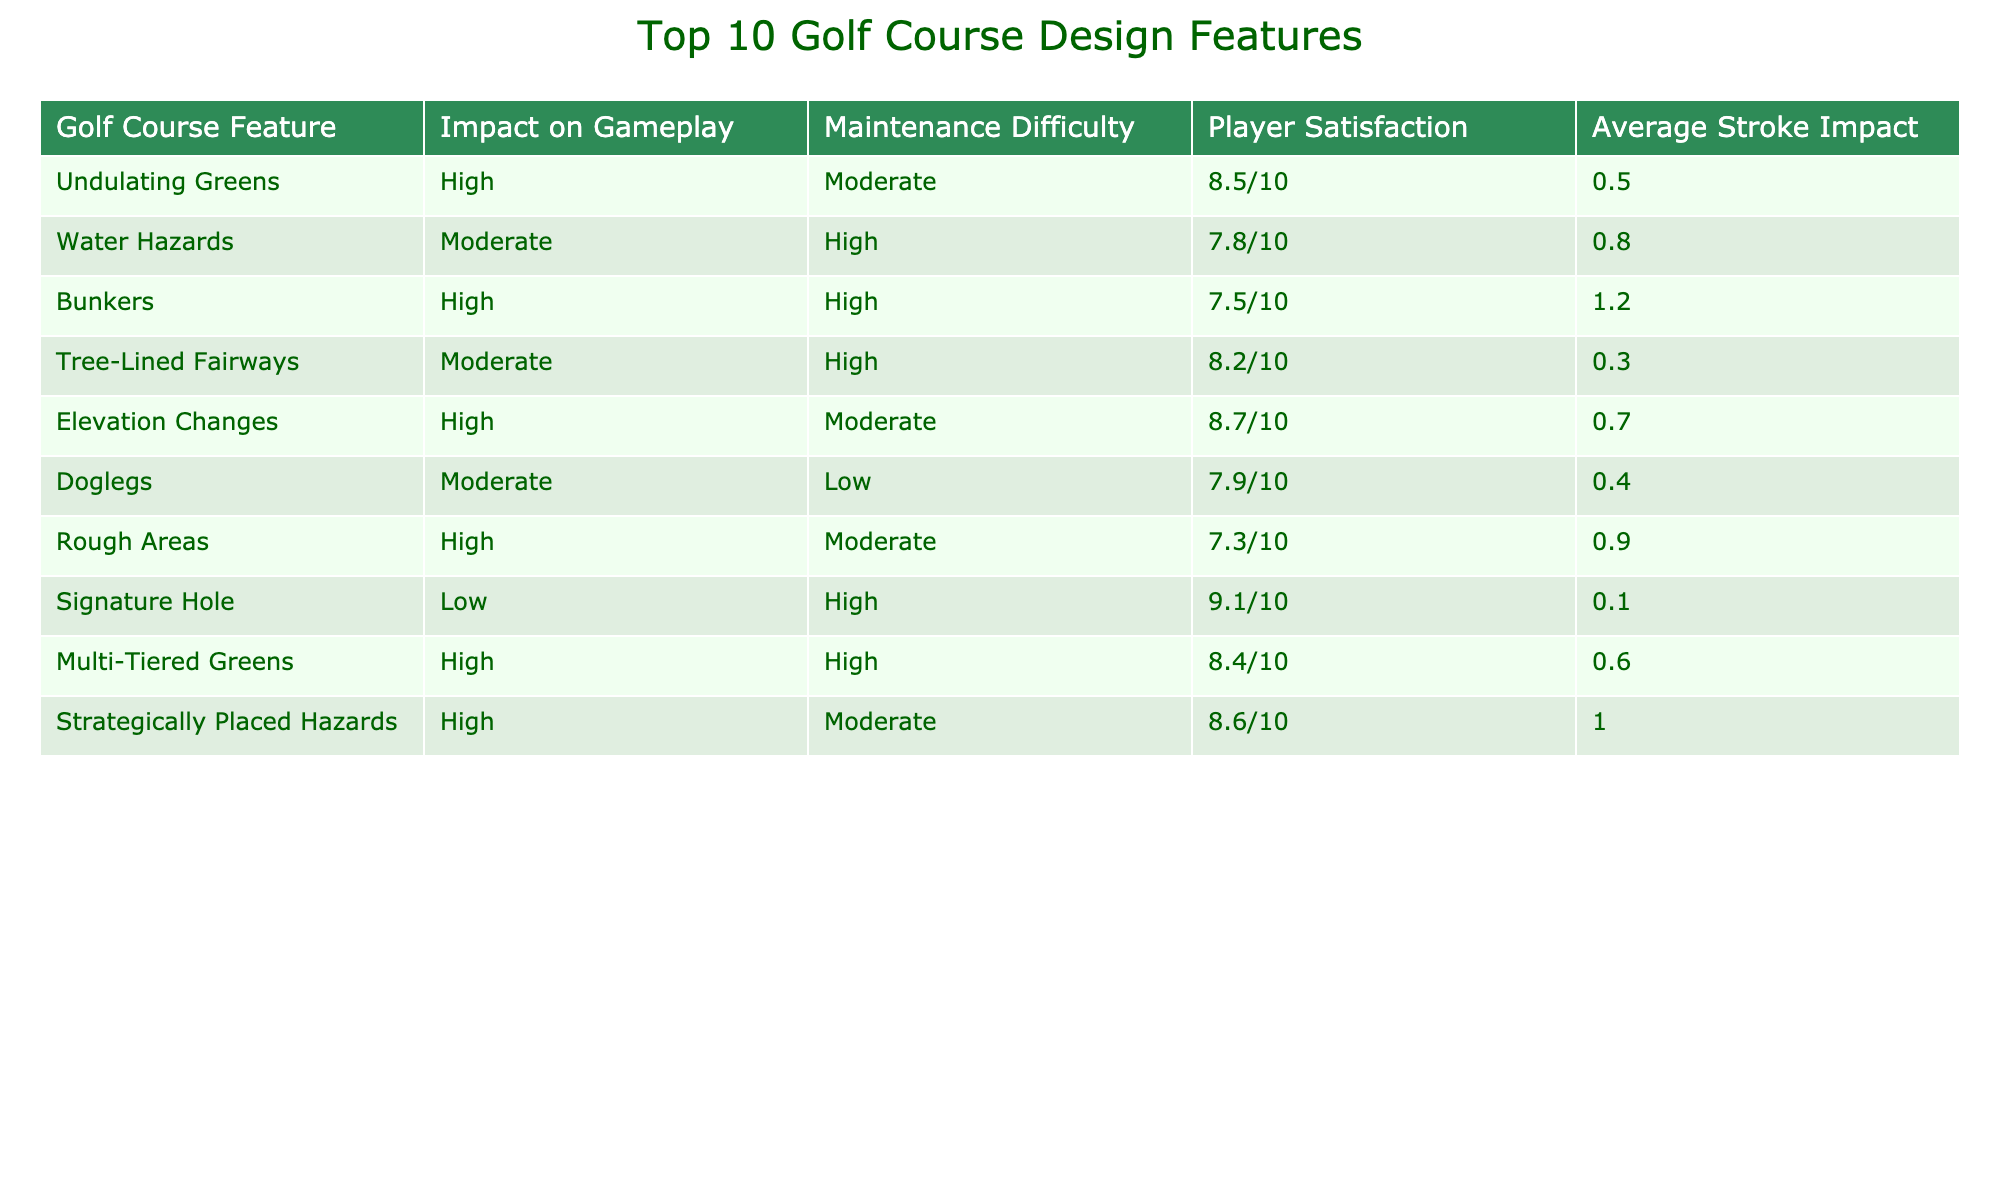What is the average player satisfaction rating for the golf course features? To find the average player satisfaction rating, we take the sum of all satisfaction ratings (8.5 + 7.8 + 7.5 + 8.2 + 8.7 + 7.9 + 7.3 + 9.1 + 8.4 + 8.6) which equals 86.6, and then divide by the number of features (10). Thus, 86.6 / 10 = 8.66.
Answer: 8.66 Which feature has the highest average stroke impact? By reviewing the "Average Stroke Impact" column, we find that Bunkers have the highest value at +1.2.
Answer: Bunkers Is "Elevation Changes" considered to have a high impact on gameplay? The table indicates that "Elevation Changes" is marked as having a "High" impact on gameplay.
Answer: Yes How many features have a maintenance difficulty rated as 'High'? The features that have maintenance difficulty rated as 'High' are Water Hazards, Bunkers, Rough Areas, Signature Hole, and Multi-Tiered Greens, making a total of 5.
Answer: 5 What is the difference in player satisfaction between "Water Hazards" and "Doglegs"? The player satisfaction rating for Water Hazards is 7.8/10, while for Doglegs it is 7.9/10. The difference is 7.9 - 7.8 = 0.1.
Answer: 0.1 Which feature has a higher maintenance difficulty: "Rough Areas" or "Tree-Lined Fairways"? The maintenance difficulty for Rough Areas is rated as "Moderate" and for Tree-Lined Fairways as "High", making Tree-Lined Fairways the one with a higher difficulty.
Answer: Tree-Lined Fairways Are there more features with high impact than those rated low impact? The features with high impact are Undulating Greens, Bunkers, Elevation Changes, Rough Areas, Multi-Tiered Greens, and Strategically Placed Hazards (6 total). The features rated as low impact are Signature Hole (1 total). Since 6 is greater than 1, this statement is true.
Answer: Yes What is the average satisfaction rating of features with high maintenance difficulty? The features with high maintenance difficulty are Water Hazards, Bunkers, Rough Areas, Signature Hole, and Multi-Tiered Greens, with satisfaction ratings of 7.8, 7.5, 7.3, 9.1, and 8.4 respectively. Summing these gives 39.1, and dividing by 5 yields an average satisfaction of 39.1 / 5 = 7.82.
Answer: 7.82 How does the average stroke impact of "Strategically Placed Hazards" compare with "Signature Hole"? The average stroke impact for Strategically Placed Hazards is +1.0, while for Signature Hole it is +0.1. The difference is +1.0 - +0.1 = +0.9, showing that Strategically Placed Hazards has a greater stroke impact.
Answer: +0.9 Is there a feature that combines high impact on gameplay and low maintenance difficulty? Evaluating the table, Doglegs has a "Moderate" impact and "Low" maintenance difficulty. So yes, it is the feature that meets these criteria.
Answer: Yes 